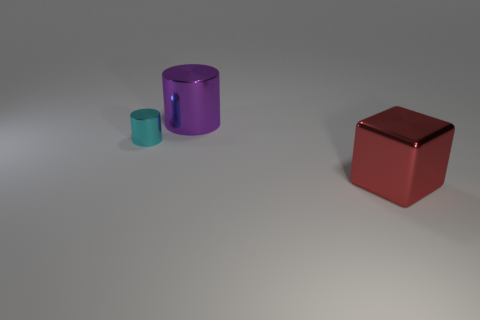Add 3 small cyan things. How many objects exist? 6 Subtract all red metal cylinders. Subtract all metallic blocks. How many objects are left? 2 Add 3 small cyan metallic cylinders. How many small cyan metallic cylinders are left? 4 Add 2 purple cylinders. How many purple cylinders exist? 3 Subtract 0 brown cylinders. How many objects are left? 3 Subtract all blocks. How many objects are left? 2 